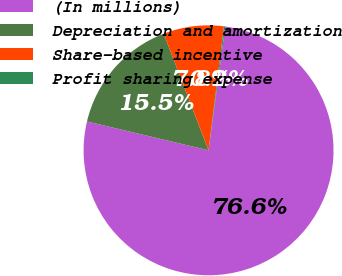Convert chart to OTSL. <chart><loc_0><loc_0><loc_500><loc_500><pie_chart><fcel>(In millions)<fcel>Depreciation and amortization<fcel>Share-based incentive<fcel>Profit sharing expense<nl><fcel>76.57%<fcel>15.45%<fcel>7.81%<fcel>0.17%<nl></chart> 